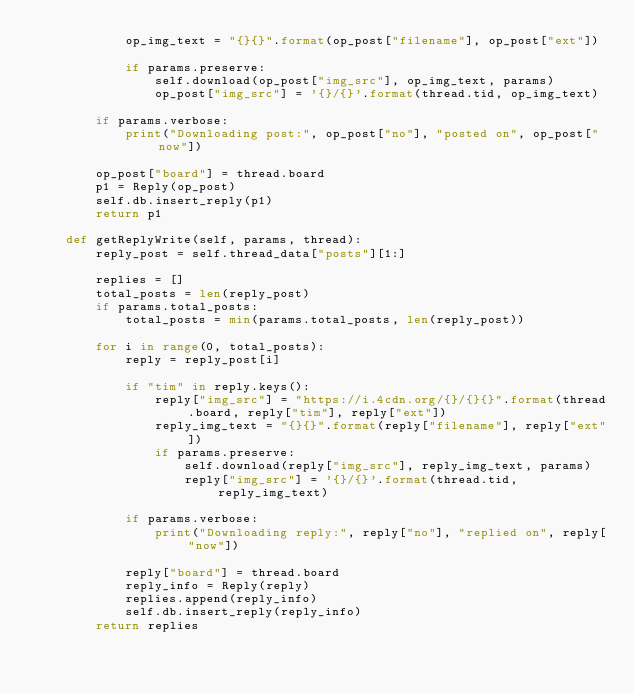Convert code to text. <code><loc_0><loc_0><loc_500><loc_500><_Python_>            op_img_text = "{}{}".format(op_post["filename"], op_post["ext"])

            if params.preserve:
                self.download(op_post["img_src"], op_img_text, params)
                op_post["img_src"] = '{}/{}'.format(thread.tid, op_img_text)

        if params.verbose:
            print("Downloading post:", op_post["no"], "posted on", op_post["now"])

        op_post["board"] = thread.board
        p1 = Reply(op_post)
        self.db.insert_reply(p1)
        return p1

    def getReplyWrite(self, params, thread):
        reply_post = self.thread_data["posts"][1:]

        replies = []
        total_posts = len(reply_post)
        if params.total_posts:
            total_posts = min(params.total_posts, len(reply_post))

        for i in range(0, total_posts):
            reply = reply_post[i]

            if "tim" in reply.keys():
                reply["img_src"] = "https://i.4cdn.org/{}/{}{}".format(thread.board, reply["tim"], reply["ext"])
                reply_img_text = "{}{}".format(reply["filename"], reply["ext"])
                if params.preserve:
                    self.download(reply["img_src"], reply_img_text, params)
                    reply["img_src"] = '{}/{}'.format(thread.tid, reply_img_text)

            if params.verbose:
                print("Downloading reply:", reply["no"], "replied on", reply["now"])

            reply["board"] = thread.board
            reply_info = Reply(reply)
            replies.append(reply_info)
            self.db.insert_reply(reply_info)
        return replies
</code> 